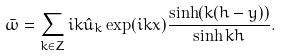<formula> <loc_0><loc_0><loc_500><loc_500>\bar { \omega } = \sum _ { k \in { Z } } i k \hat { u } _ { k } \exp ( i k x ) \frac { \sinh ( k ( h - y ) ) } { \sinh k h } .</formula> 